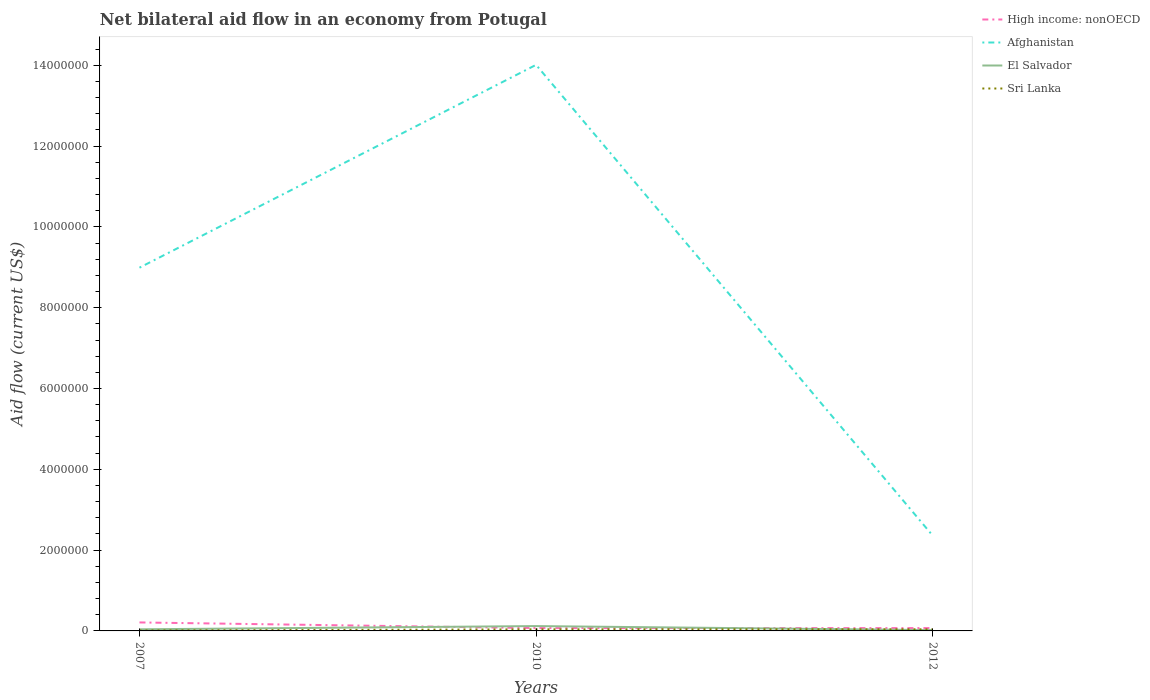How many different coloured lines are there?
Make the answer very short. 4. Does the line corresponding to Afghanistan intersect with the line corresponding to High income: nonOECD?
Your response must be concise. No. Is the number of lines equal to the number of legend labels?
Your response must be concise. Yes. In which year was the net bilateral aid flow in Afghanistan maximum?
Ensure brevity in your answer.  2012. What is the difference between the highest and the second highest net bilateral aid flow in El Salvador?
Ensure brevity in your answer.  1.00e+05. What is the difference between the highest and the lowest net bilateral aid flow in High income: nonOECD?
Offer a very short reply. 1. How many lines are there?
Provide a short and direct response. 4. How many years are there in the graph?
Ensure brevity in your answer.  3. What is the difference between two consecutive major ticks on the Y-axis?
Provide a succinct answer. 2.00e+06. How many legend labels are there?
Offer a terse response. 4. How are the legend labels stacked?
Ensure brevity in your answer.  Vertical. What is the title of the graph?
Offer a terse response. Net bilateral aid flow in an economy from Potugal. Does "Azerbaijan" appear as one of the legend labels in the graph?
Keep it short and to the point. No. What is the Aid flow (current US$) of High income: nonOECD in 2007?
Your response must be concise. 2.10e+05. What is the Aid flow (current US$) of Afghanistan in 2007?
Provide a short and direct response. 8.99e+06. What is the Aid flow (current US$) in El Salvador in 2007?
Make the answer very short. 4.00e+04. What is the Aid flow (current US$) in High income: nonOECD in 2010?
Ensure brevity in your answer.  7.00e+04. What is the Aid flow (current US$) in Afghanistan in 2010?
Keep it short and to the point. 1.40e+07. What is the Aid flow (current US$) of Sri Lanka in 2010?
Provide a short and direct response. 4.00e+04. What is the Aid flow (current US$) in High income: nonOECD in 2012?
Your answer should be very brief. 7.00e+04. What is the Aid flow (current US$) of Afghanistan in 2012?
Make the answer very short. 2.36e+06. Across all years, what is the maximum Aid flow (current US$) of High income: nonOECD?
Your answer should be very brief. 2.10e+05. Across all years, what is the maximum Aid flow (current US$) in Afghanistan?
Your response must be concise. 1.40e+07. Across all years, what is the minimum Aid flow (current US$) in High income: nonOECD?
Offer a terse response. 7.00e+04. Across all years, what is the minimum Aid flow (current US$) of Afghanistan?
Your answer should be very brief. 2.36e+06. Across all years, what is the minimum Aid flow (current US$) of El Salvador?
Give a very brief answer. 2.00e+04. What is the total Aid flow (current US$) in High income: nonOECD in the graph?
Your response must be concise. 3.50e+05. What is the total Aid flow (current US$) of Afghanistan in the graph?
Give a very brief answer. 2.54e+07. What is the total Aid flow (current US$) of El Salvador in the graph?
Keep it short and to the point. 1.80e+05. What is the difference between the Aid flow (current US$) of High income: nonOECD in 2007 and that in 2010?
Make the answer very short. 1.40e+05. What is the difference between the Aid flow (current US$) of Afghanistan in 2007 and that in 2010?
Make the answer very short. -5.02e+06. What is the difference between the Aid flow (current US$) in El Salvador in 2007 and that in 2010?
Give a very brief answer. -8.00e+04. What is the difference between the Aid flow (current US$) in High income: nonOECD in 2007 and that in 2012?
Provide a short and direct response. 1.40e+05. What is the difference between the Aid flow (current US$) of Afghanistan in 2007 and that in 2012?
Give a very brief answer. 6.63e+06. What is the difference between the Aid flow (current US$) in Sri Lanka in 2007 and that in 2012?
Your answer should be very brief. -3.00e+04. What is the difference between the Aid flow (current US$) of Afghanistan in 2010 and that in 2012?
Make the answer very short. 1.16e+07. What is the difference between the Aid flow (current US$) of El Salvador in 2010 and that in 2012?
Your response must be concise. 1.00e+05. What is the difference between the Aid flow (current US$) of Sri Lanka in 2010 and that in 2012?
Ensure brevity in your answer.  0. What is the difference between the Aid flow (current US$) in High income: nonOECD in 2007 and the Aid flow (current US$) in Afghanistan in 2010?
Your response must be concise. -1.38e+07. What is the difference between the Aid flow (current US$) in High income: nonOECD in 2007 and the Aid flow (current US$) in El Salvador in 2010?
Provide a succinct answer. 9.00e+04. What is the difference between the Aid flow (current US$) in Afghanistan in 2007 and the Aid flow (current US$) in El Salvador in 2010?
Keep it short and to the point. 8.87e+06. What is the difference between the Aid flow (current US$) in Afghanistan in 2007 and the Aid flow (current US$) in Sri Lanka in 2010?
Offer a very short reply. 8.95e+06. What is the difference between the Aid flow (current US$) in High income: nonOECD in 2007 and the Aid flow (current US$) in Afghanistan in 2012?
Provide a short and direct response. -2.15e+06. What is the difference between the Aid flow (current US$) of High income: nonOECD in 2007 and the Aid flow (current US$) of Sri Lanka in 2012?
Ensure brevity in your answer.  1.70e+05. What is the difference between the Aid flow (current US$) in Afghanistan in 2007 and the Aid flow (current US$) in El Salvador in 2012?
Ensure brevity in your answer.  8.97e+06. What is the difference between the Aid flow (current US$) of Afghanistan in 2007 and the Aid flow (current US$) of Sri Lanka in 2012?
Your answer should be compact. 8.95e+06. What is the difference between the Aid flow (current US$) of High income: nonOECD in 2010 and the Aid flow (current US$) of Afghanistan in 2012?
Your response must be concise. -2.29e+06. What is the difference between the Aid flow (current US$) of Afghanistan in 2010 and the Aid flow (current US$) of El Salvador in 2012?
Your answer should be very brief. 1.40e+07. What is the difference between the Aid flow (current US$) in Afghanistan in 2010 and the Aid flow (current US$) in Sri Lanka in 2012?
Give a very brief answer. 1.40e+07. What is the average Aid flow (current US$) of High income: nonOECD per year?
Your response must be concise. 1.17e+05. What is the average Aid flow (current US$) of Afghanistan per year?
Offer a very short reply. 8.45e+06. In the year 2007, what is the difference between the Aid flow (current US$) of High income: nonOECD and Aid flow (current US$) of Afghanistan?
Ensure brevity in your answer.  -8.78e+06. In the year 2007, what is the difference between the Aid flow (current US$) in Afghanistan and Aid flow (current US$) in El Salvador?
Your answer should be very brief. 8.95e+06. In the year 2007, what is the difference between the Aid flow (current US$) in Afghanistan and Aid flow (current US$) in Sri Lanka?
Make the answer very short. 8.98e+06. In the year 2010, what is the difference between the Aid flow (current US$) of High income: nonOECD and Aid flow (current US$) of Afghanistan?
Provide a short and direct response. -1.39e+07. In the year 2010, what is the difference between the Aid flow (current US$) in Afghanistan and Aid flow (current US$) in El Salvador?
Keep it short and to the point. 1.39e+07. In the year 2010, what is the difference between the Aid flow (current US$) of Afghanistan and Aid flow (current US$) of Sri Lanka?
Your answer should be compact. 1.40e+07. In the year 2010, what is the difference between the Aid flow (current US$) in El Salvador and Aid flow (current US$) in Sri Lanka?
Ensure brevity in your answer.  8.00e+04. In the year 2012, what is the difference between the Aid flow (current US$) in High income: nonOECD and Aid flow (current US$) in Afghanistan?
Provide a short and direct response. -2.29e+06. In the year 2012, what is the difference between the Aid flow (current US$) in High income: nonOECD and Aid flow (current US$) in El Salvador?
Your response must be concise. 5.00e+04. In the year 2012, what is the difference between the Aid flow (current US$) of Afghanistan and Aid flow (current US$) of El Salvador?
Your answer should be compact. 2.34e+06. In the year 2012, what is the difference between the Aid flow (current US$) in Afghanistan and Aid flow (current US$) in Sri Lanka?
Offer a very short reply. 2.32e+06. What is the ratio of the Aid flow (current US$) of High income: nonOECD in 2007 to that in 2010?
Your response must be concise. 3. What is the ratio of the Aid flow (current US$) in Afghanistan in 2007 to that in 2010?
Ensure brevity in your answer.  0.64. What is the ratio of the Aid flow (current US$) in Sri Lanka in 2007 to that in 2010?
Provide a short and direct response. 0.25. What is the ratio of the Aid flow (current US$) of High income: nonOECD in 2007 to that in 2012?
Your answer should be very brief. 3. What is the ratio of the Aid flow (current US$) of Afghanistan in 2007 to that in 2012?
Provide a short and direct response. 3.81. What is the ratio of the Aid flow (current US$) in Sri Lanka in 2007 to that in 2012?
Provide a succinct answer. 0.25. What is the ratio of the Aid flow (current US$) of Afghanistan in 2010 to that in 2012?
Provide a succinct answer. 5.94. What is the ratio of the Aid flow (current US$) of Sri Lanka in 2010 to that in 2012?
Keep it short and to the point. 1. What is the difference between the highest and the second highest Aid flow (current US$) in High income: nonOECD?
Offer a very short reply. 1.40e+05. What is the difference between the highest and the second highest Aid flow (current US$) of Afghanistan?
Provide a succinct answer. 5.02e+06. What is the difference between the highest and the lowest Aid flow (current US$) of Afghanistan?
Your response must be concise. 1.16e+07. What is the difference between the highest and the lowest Aid flow (current US$) of Sri Lanka?
Ensure brevity in your answer.  3.00e+04. 